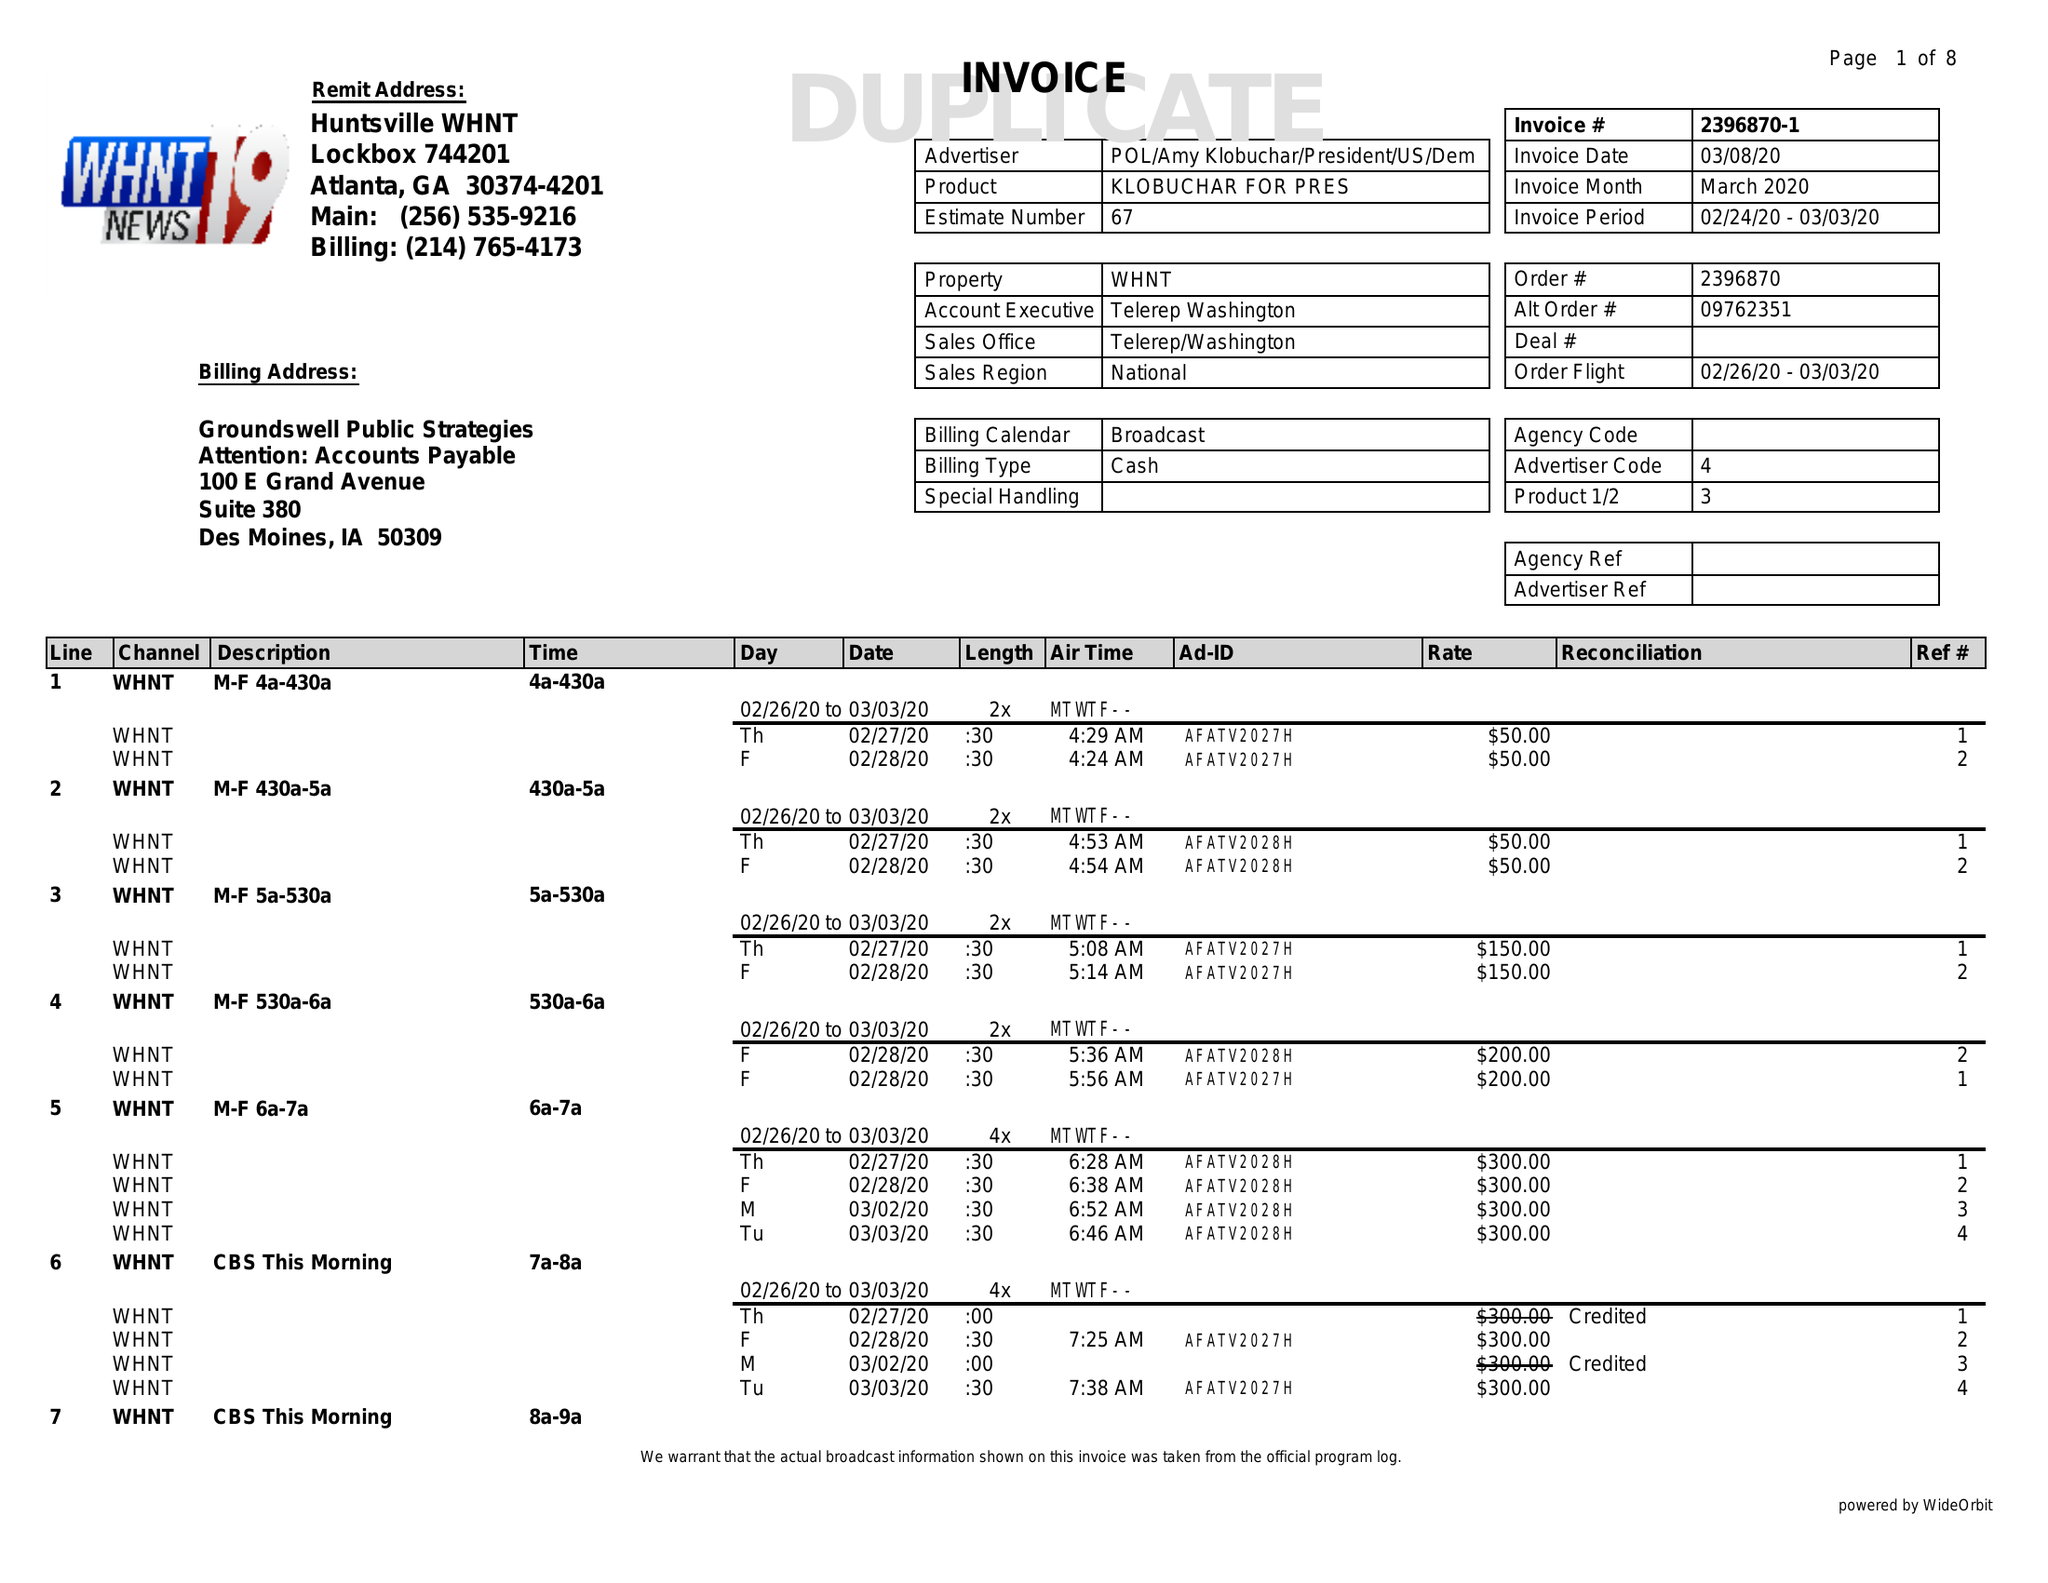What is the value for the flight_to?
Answer the question using a single word or phrase. 03/03/20 